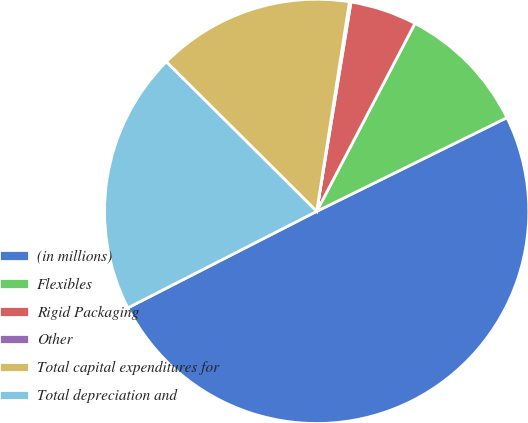Convert chart to OTSL. <chart><loc_0><loc_0><loc_500><loc_500><pie_chart><fcel>(in millions)<fcel>Flexibles<fcel>Rigid Packaging<fcel>Other<fcel>Total capital expenditures for<fcel>Total depreciation and<nl><fcel>49.77%<fcel>10.05%<fcel>5.08%<fcel>0.12%<fcel>15.01%<fcel>19.98%<nl></chart> 